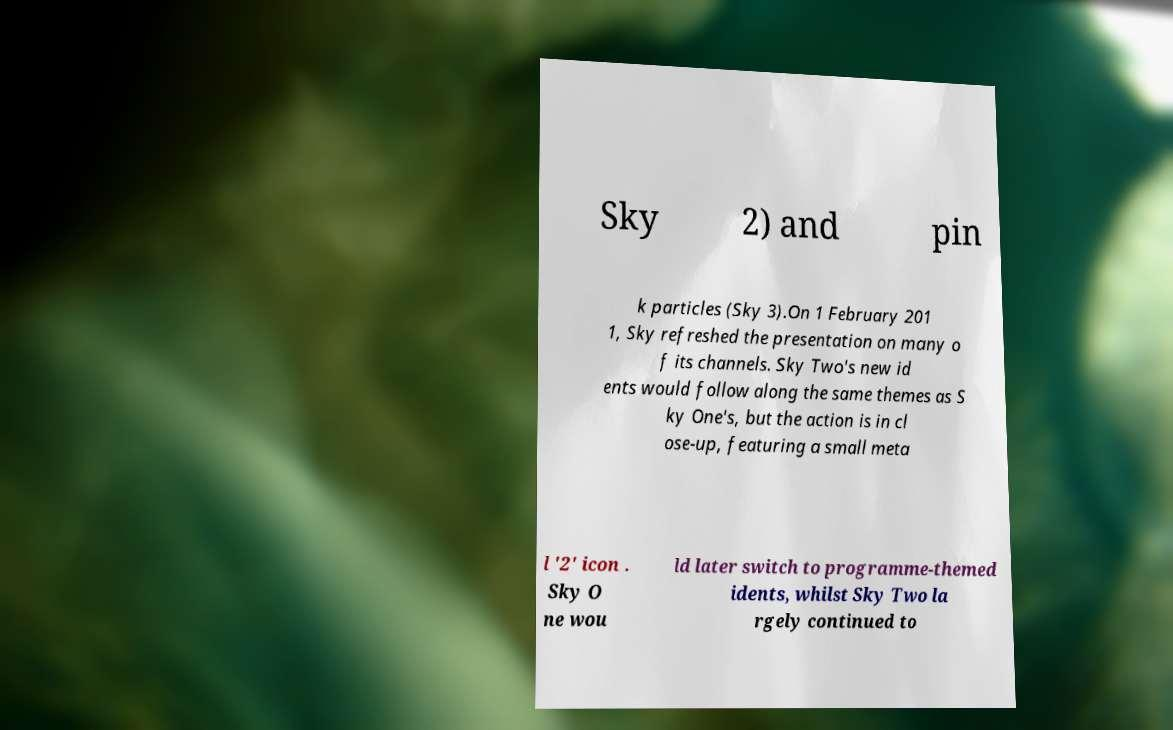Can you read and provide the text displayed in the image?This photo seems to have some interesting text. Can you extract and type it out for me? Sky 2) and pin k particles (Sky 3).On 1 February 201 1, Sky refreshed the presentation on many o f its channels. Sky Two's new id ents would follow along the same themes as S ky One's, but the action is in cl ose-up, featuring a small meta l '2' icon . Sky O ne wou ld later switch to programme-themed idents, whilst Sky Two la rgely continued to 